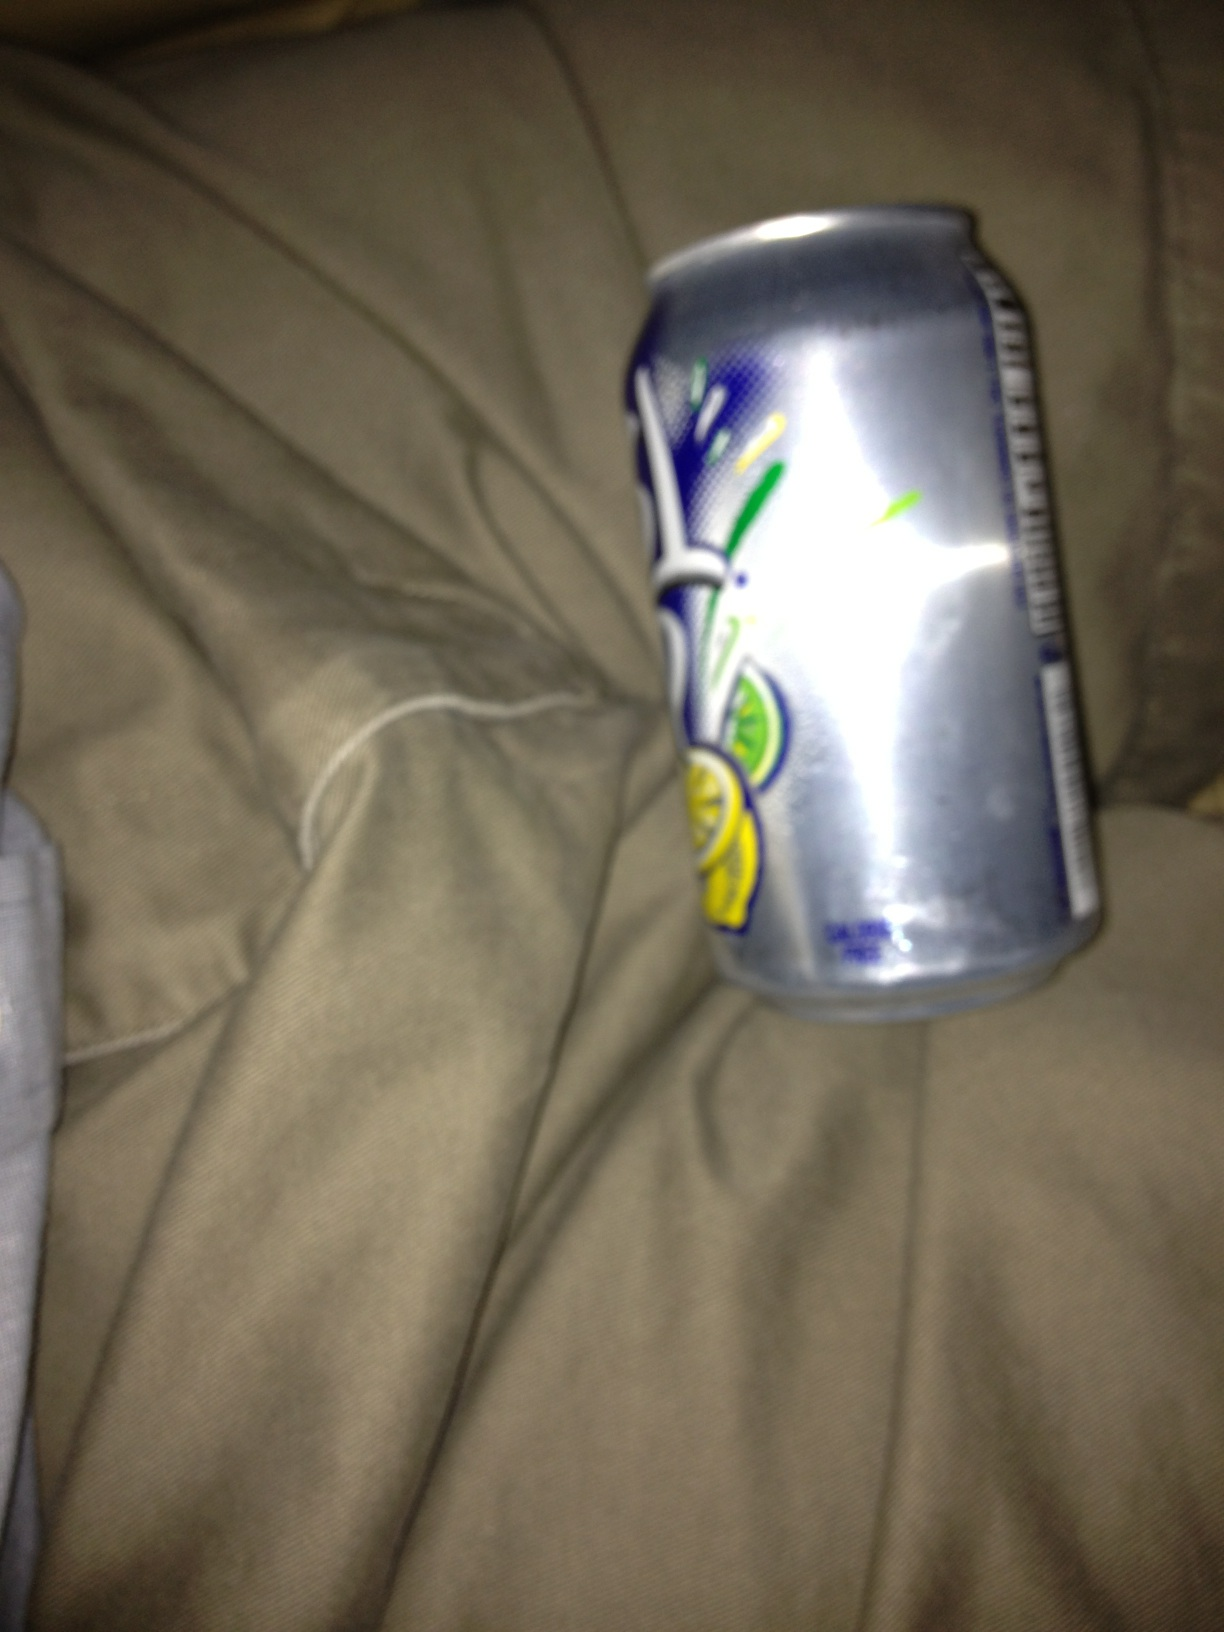Where could this picture have been taken? The image appears to have been taken in a casual, perhaps personal setting, likely on a cloth-covered surface such as a couch or bed. Is there any indication of time or specific location from the image? There are no clear indicators of time or specific geographic location visible in the image. The focus is solely on the crumpled can against a nondescript fabric background. 